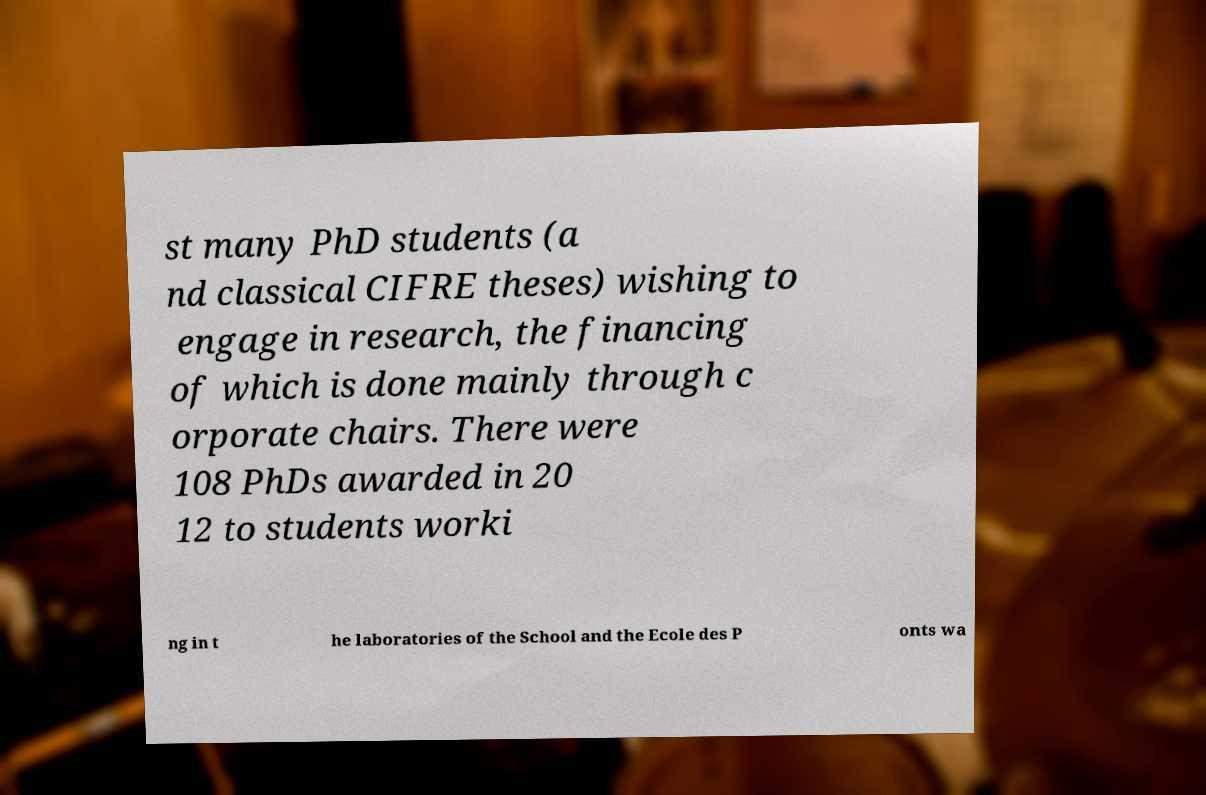Can you accurately transcribe the text from the provided image for me? st many PhD students (a nd classical CIFRE theses) wishing to engage in research, the financing of which is done mainly through c orporate chairs. There were 108 PhDs awarded in 20 12 to students worki ng in t he laboratories of the School and the Ecole des P onts wa 